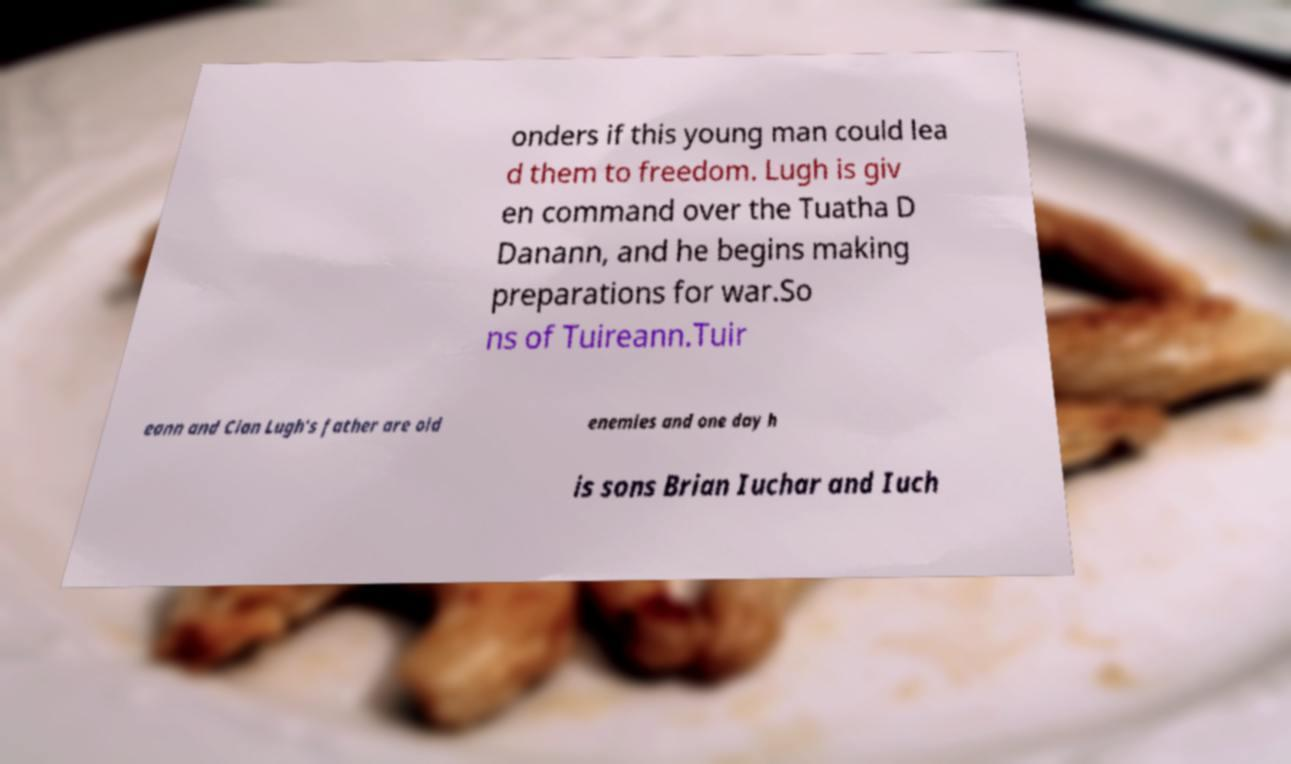What messages or text are displayed in this image? I need them in a readable, typed format. onders if this young man could lea d them to freedom. Lugh is giv en command over the Tuatha D Danann, and he begins making preparations for war.So ns of Tuireann.Tuir eann and Cian Lugh's father are old enemies and one day h is sons Brian Iuchar and Iuch 